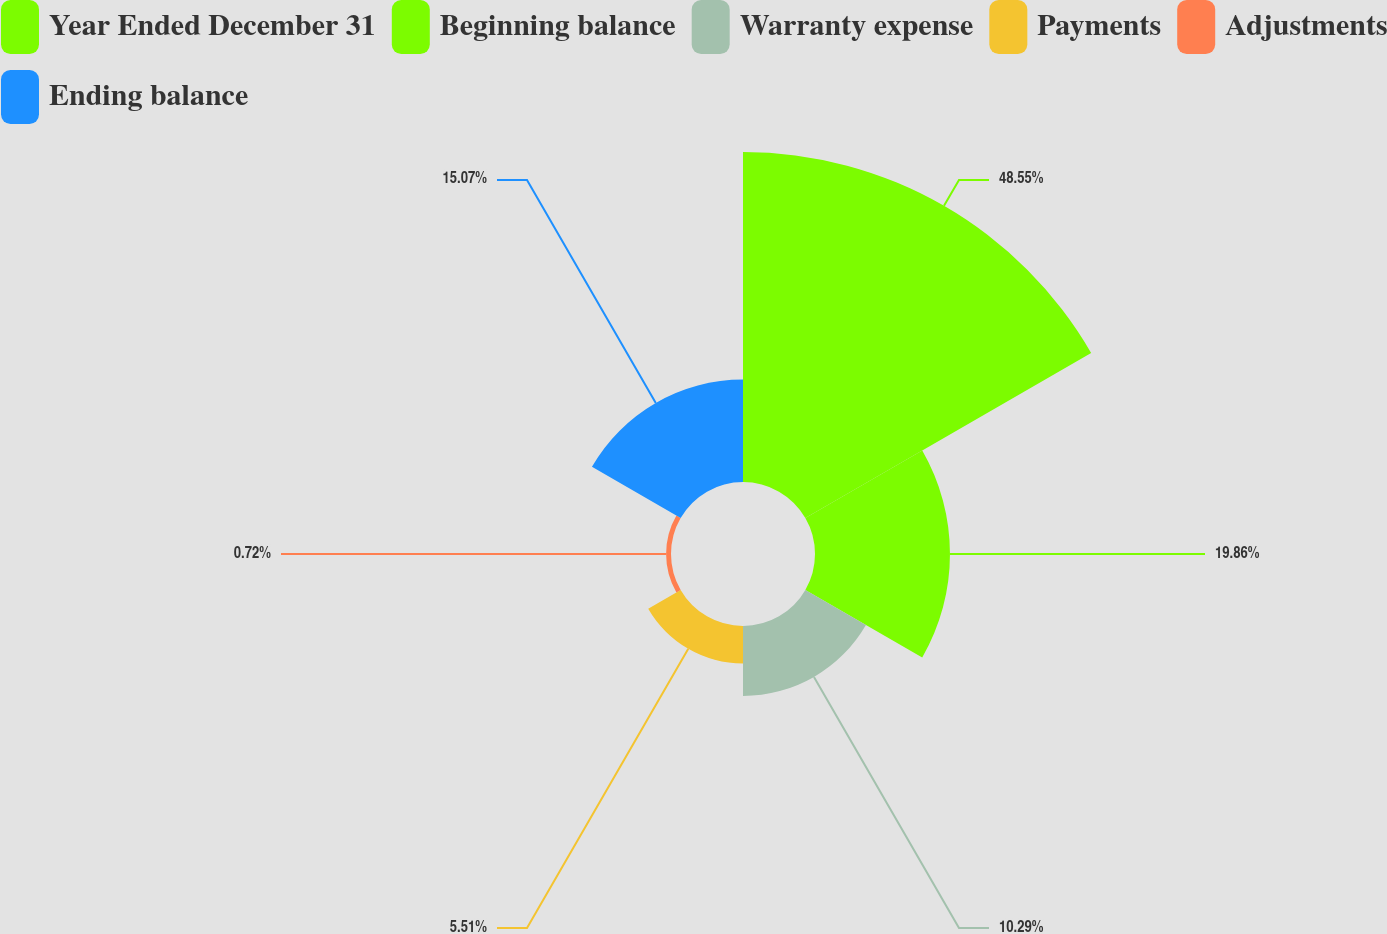Convert chart to OTSL. <chart><loc_0><loc_0><loc_500><loc_500><pie_chart><fcel>Year Ended December 31<fcel>Beginning balance<fcel>Warranty expense<fcel>Payments<fcel>Adjustments<fcel>Ending balance<nl><fcel>48.56%<fcel>19.86%<fcel>10.29%<fcel>5.51%<fcel>0.72%<fcel>15.07%<nl></chart> 